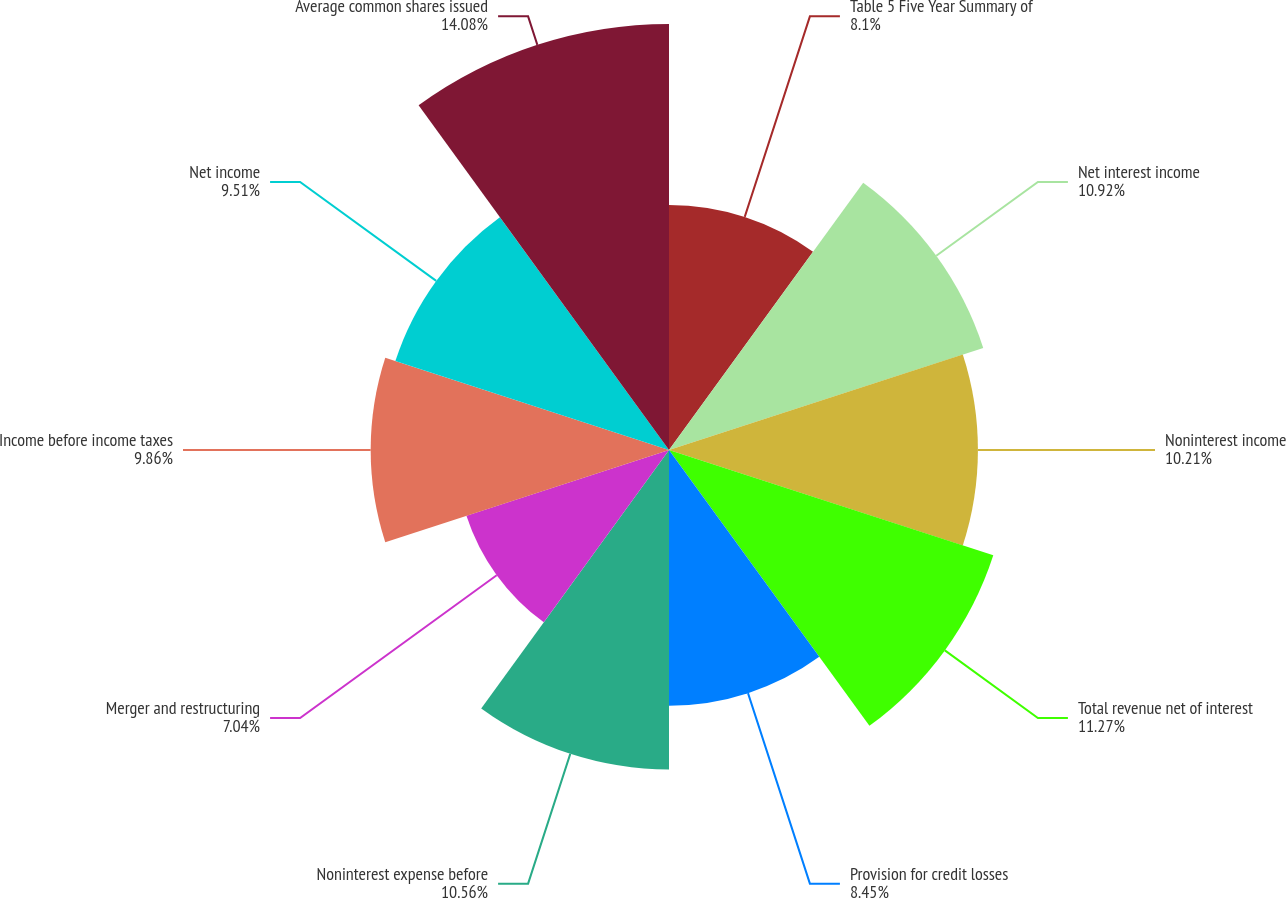Convert chart. <chart><loc_0><loc_0><loc_500><loc_500><pie_chart><fcel>Table 5 Five Year Summary of<fcel>Net interest income<fcel>Noninterest income<fcel>Total revenue net of interest<fcel>Provision for credit losses<fcel>Noninterest expense before<fcel>Merger and restructuring<fcel>Income before income taxes<fcel>Net income<fcel>Average common shares issued<nl><fcel>8.1%<fcel>10.92%<fcel>10.21%<fcel>11.27%<fcel>8.45%<fcel>10.56%<fcel>7.04%<fcel>9.86%<fcel>9.51%<fcel>14.08%<nl></chart> 